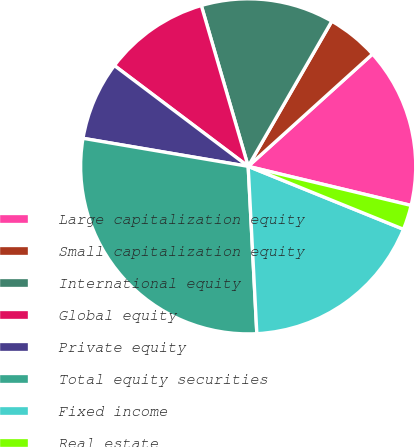Convert chart to OTSL. <chart><loc_0><loc_0><loc_500><loc_500><pie_chart><fcel>Large capitalization equity<fcel>Small capitalization equity<fcel>International equity<fcel>Global equity<fcel>Private equity<fcel>Total equity securities<fcel>Fixed income<fcel>Real estate<nl><fcel>15.44%<fcel>4.99%<fcel>12.83%<fcel>10.21%<fcel>7.6%<fcel>28.5%<fcel>18.05%<fcel>2.38%<nl></chart> 